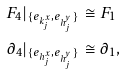<formula> <loc_0><loc_0><loc_500><loc_500>F _ { 4 } | _ { \{ e _ { k _ { j } ^ { x } } , e _ { h _ { j } ^ { y } } \} } & \cong F _ { 1 } \\ \partial _ { 4 } | _ { \{ e _ { h _ { j } ^ { x } } , e _ { h _ { j } ^ { y } } \} } & \cong \partial _ { 1 } ,</formula> 